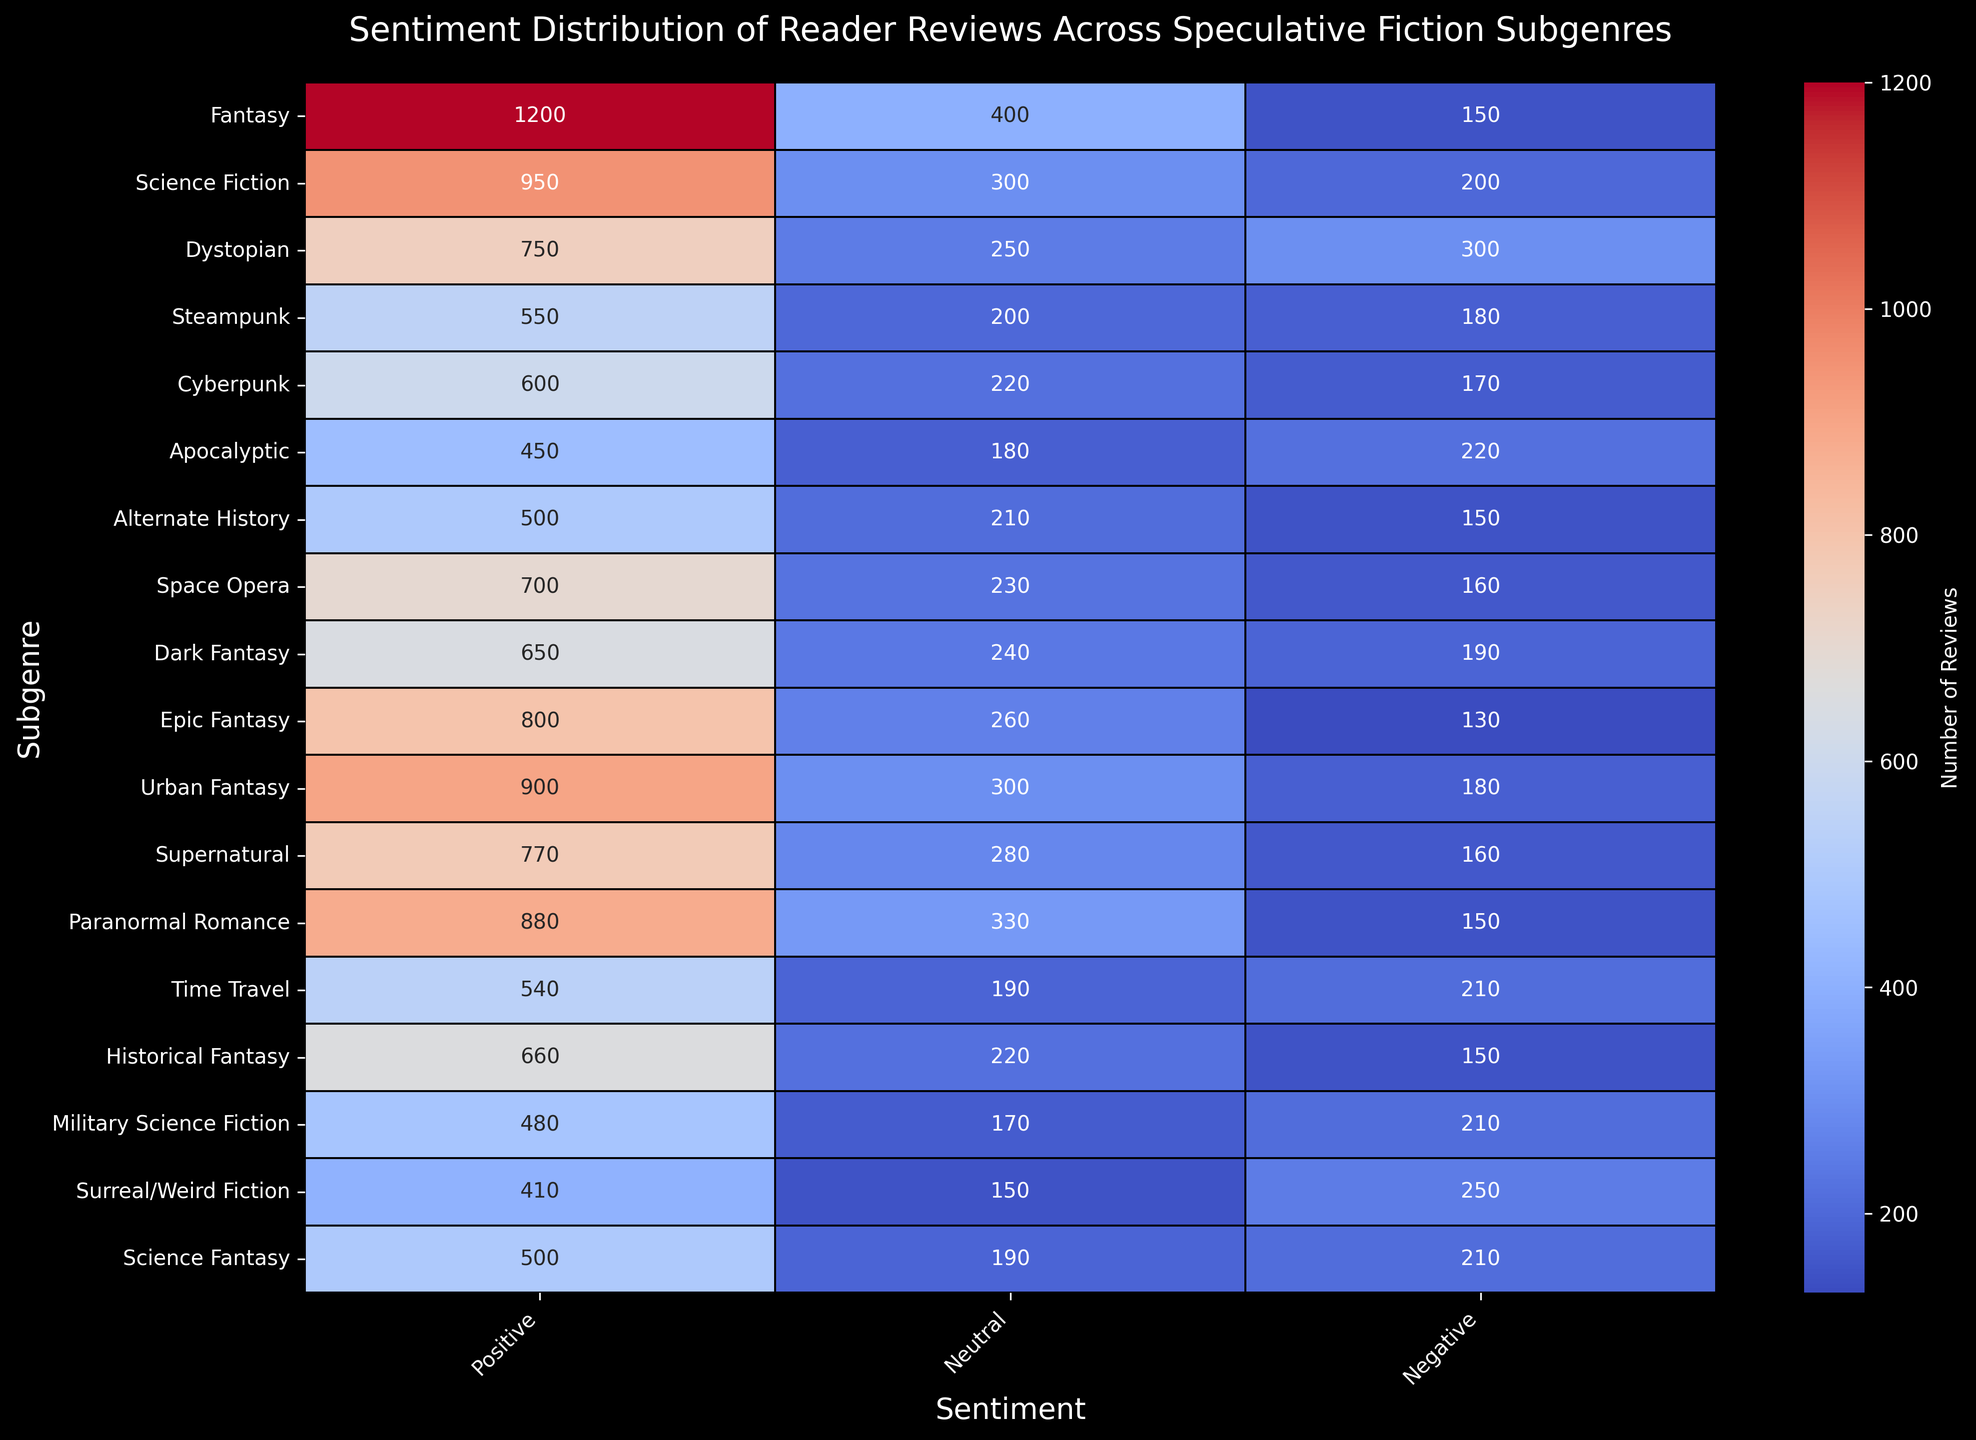Which subgenre has the highest number of positive reviews? Look at the column labeled "Positive" and find the highest number, which is 1200 in the "Fantasy" row.
Answer: Fantasy Which two subgenres have the same number of negative reviews? Look at the column labeled "Negative" to identify the subgenres with the same value. "Alternate History" and "Paranormal Romance" each have 150 negative reviews.
Answer: Alternate History and Paranormal Romance Which subgenre has more neutral reviews, Cyberpunk or Steampunk? Compare the values in the "Neutral" column for Cyberpunk (220) and Steampunk (200). Cyberpunk has more.
Answer: Cyberpunk What is the total number of positive reviews for both Urban Fantasy and Epic Fantasy? Add the "Positive" values for Urban Fantasy (900) and Epic Fantasy (800). 900 + 800 = 1700.
Answer: 1700 What is the average number of negative reviews for Apocalyptic, Paranormal Romance, and Dystopian? Add the "Negative" values for Apocalyptic (220), Paranormal Romance (150), and Dystopian (300), and divide by 3. (220 + 150 + 300) / 3 = 670 / 3 ≈ 223.33
Answer: 223.33 Which subgenre has the lowest number of combined positive, neutral, and negative reviews? Sum the columns for each subgenre and identify the smallest total. Summing: Surreal/Weird Fiction (410 + 150 + 250) = 810 has the smallest total.
Answer: Surreal/Weird Fiction In which subgenre is the ratio of positive to negative reviews closest to 4:1? Calculate the ratio (Positive/Negative) for each subgenre and find the closest to 4 (which is 4:1). Paranormal Romance has the closest ratio (880/150 ≈ 5.87). The subgenre closest to 4:1 without being rounded off is Apocalyptic (450/220 ≈ 2.05).
Answer: Paranormal Romance Which subgenre has more positive reviews than negative reviews by exactly 650? Calculate the difference between "Positive" and "Negative" for each subgenre and check which is 650. For Urban Fantasy, 900 (Positive) - 180 (Negative) = 720, but for Fantasy, 1200 (Positive) - 150 (Negative) = 1050. None fit exactly 650, but for Historical Fantasy, 660 (Positive) - 150 (Negative) = 510. Cyberpunk, however, 600 (Positive) - 170 (Negative) = 430. Apocalyptic again, 450 (Positive) - 220 (Negative) = 230.
Answer: None, closest within mentioned ratio is Paranormal Romance 